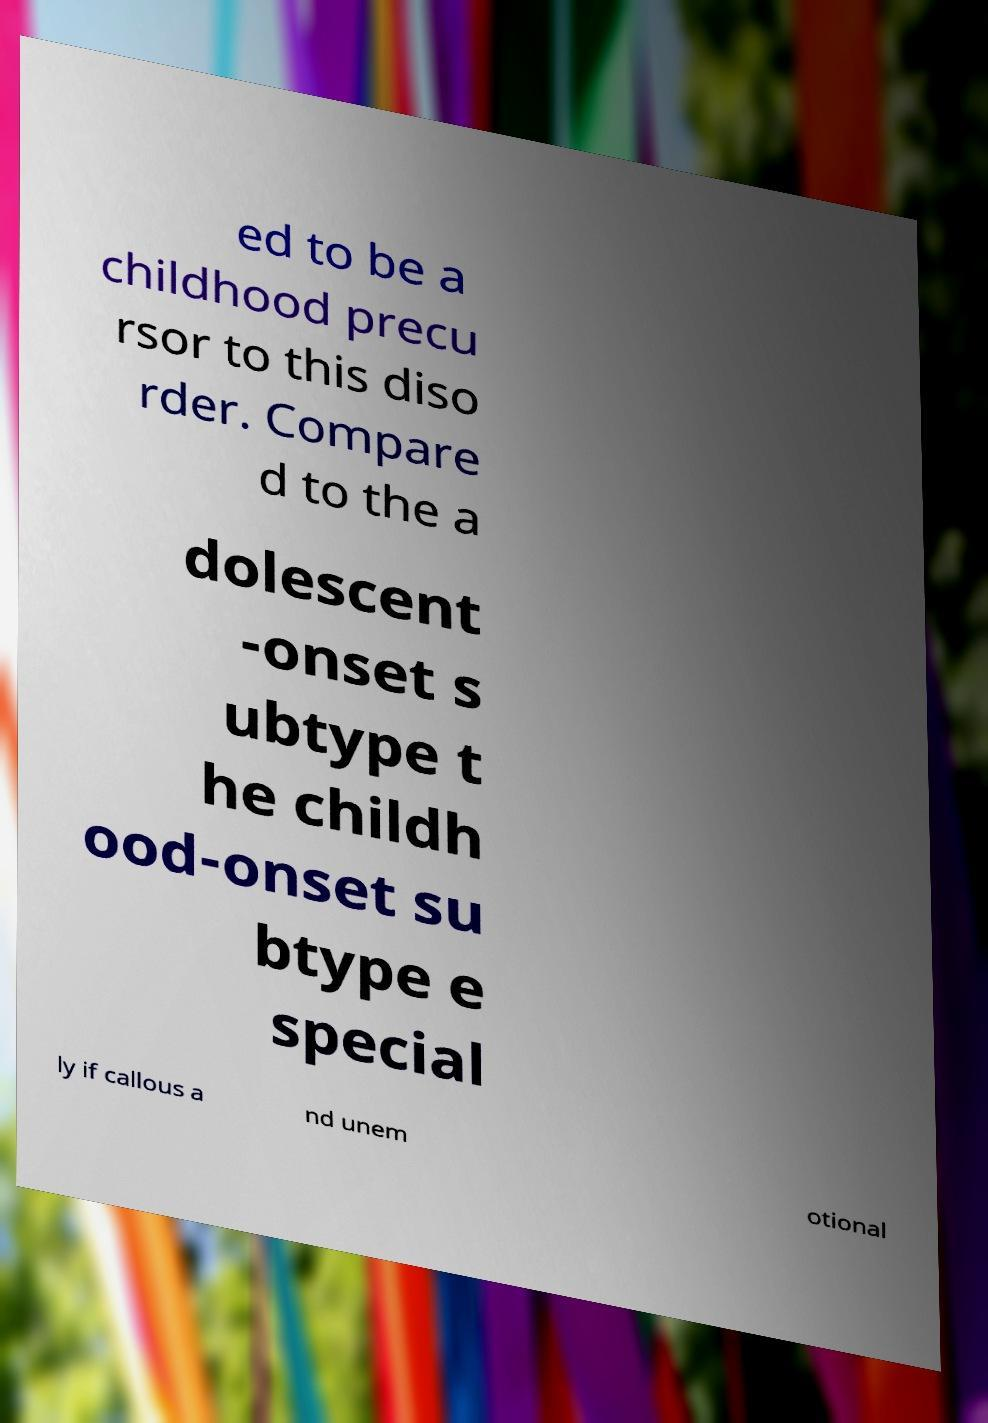For documentation purposes, I need the text within this image transcribed. Could you provide that? ed to be a childhood precu rsor to this diso rder. Compare d to the a dolescent -onset s ubtype t he childh ood-onset su btype e special ly if callous a nd unem otional 